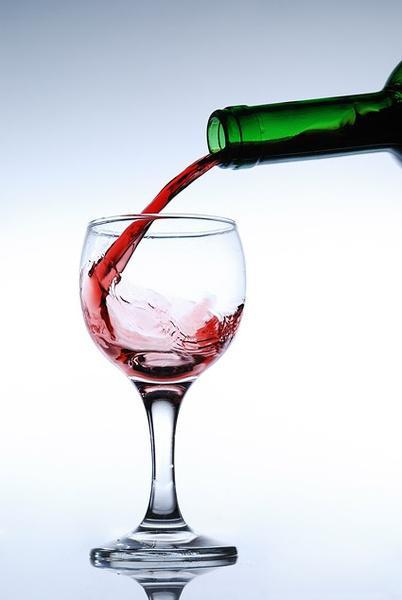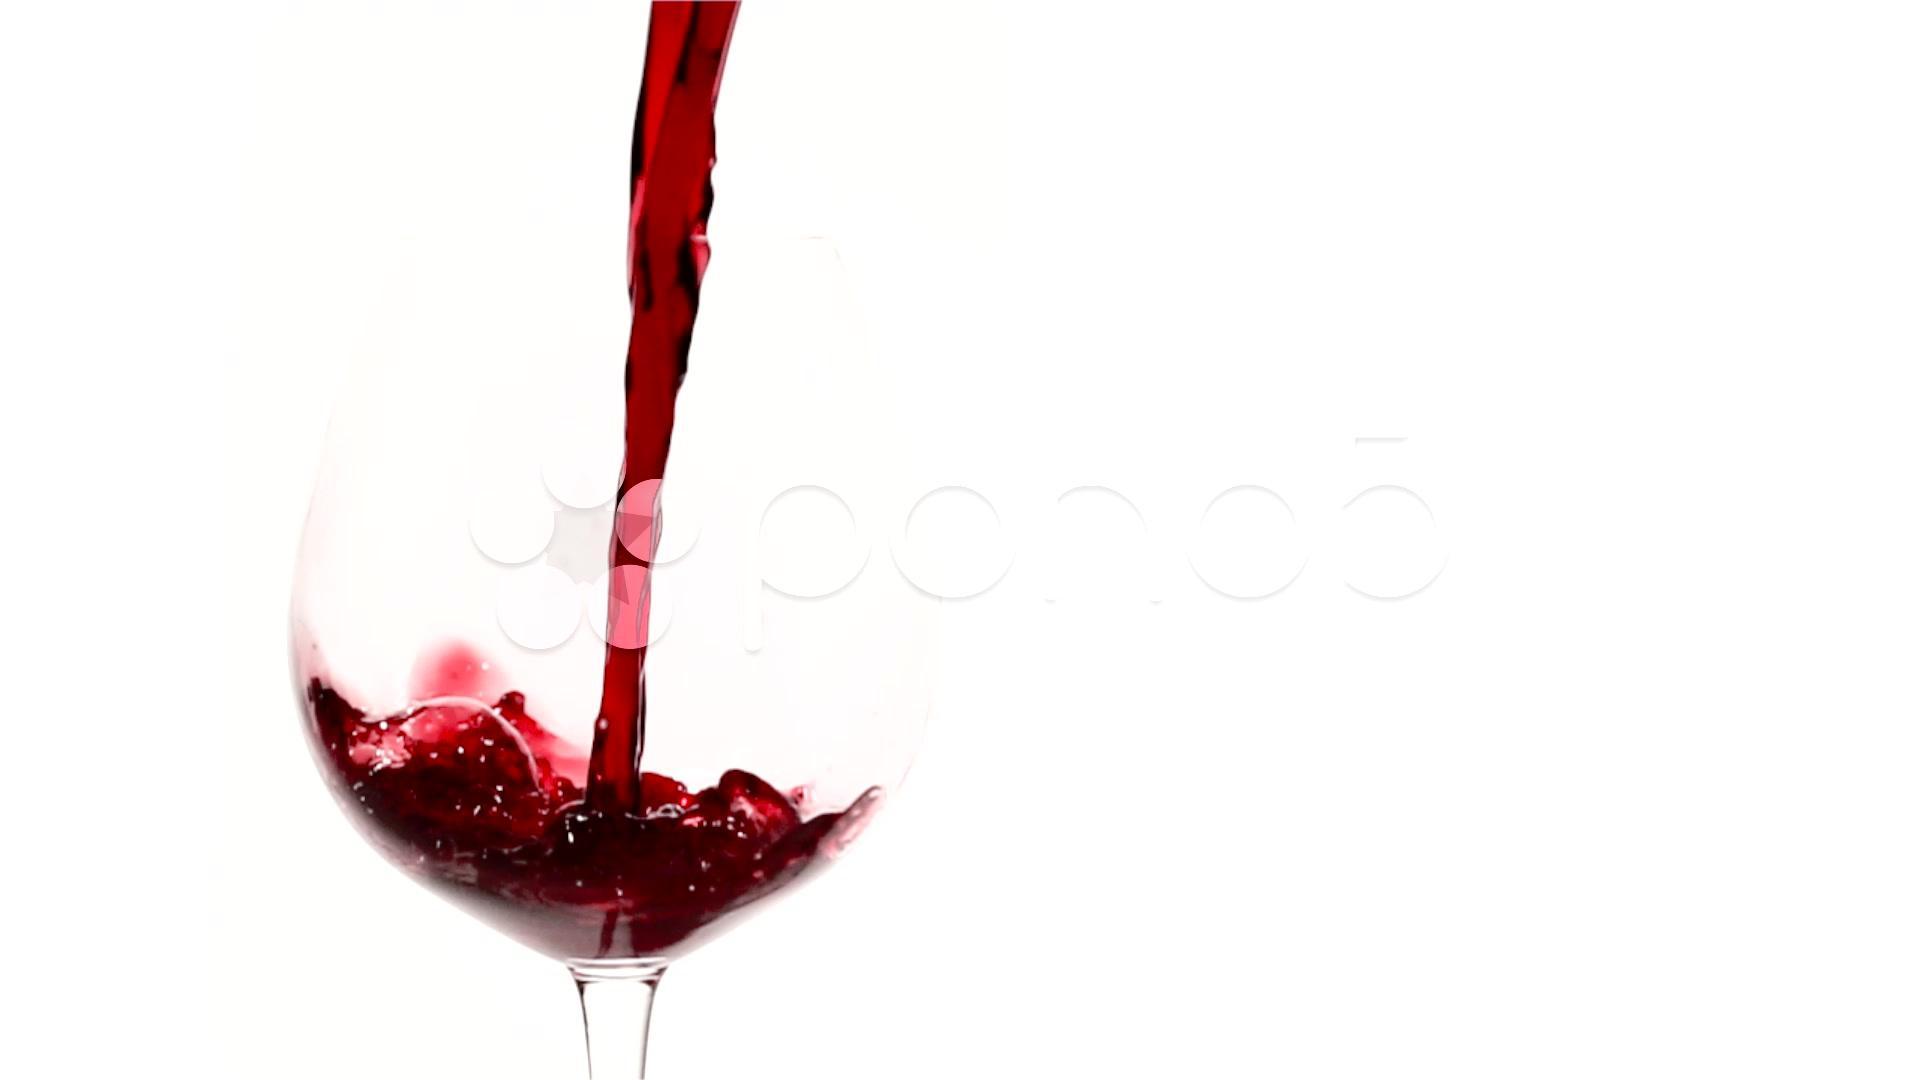The first image is the image on the left, the second image is the image on the right. Examine the images to the left and right. Is the description "At least one image has more than one wine glass in it." accurate? Answer yes or no. No. 